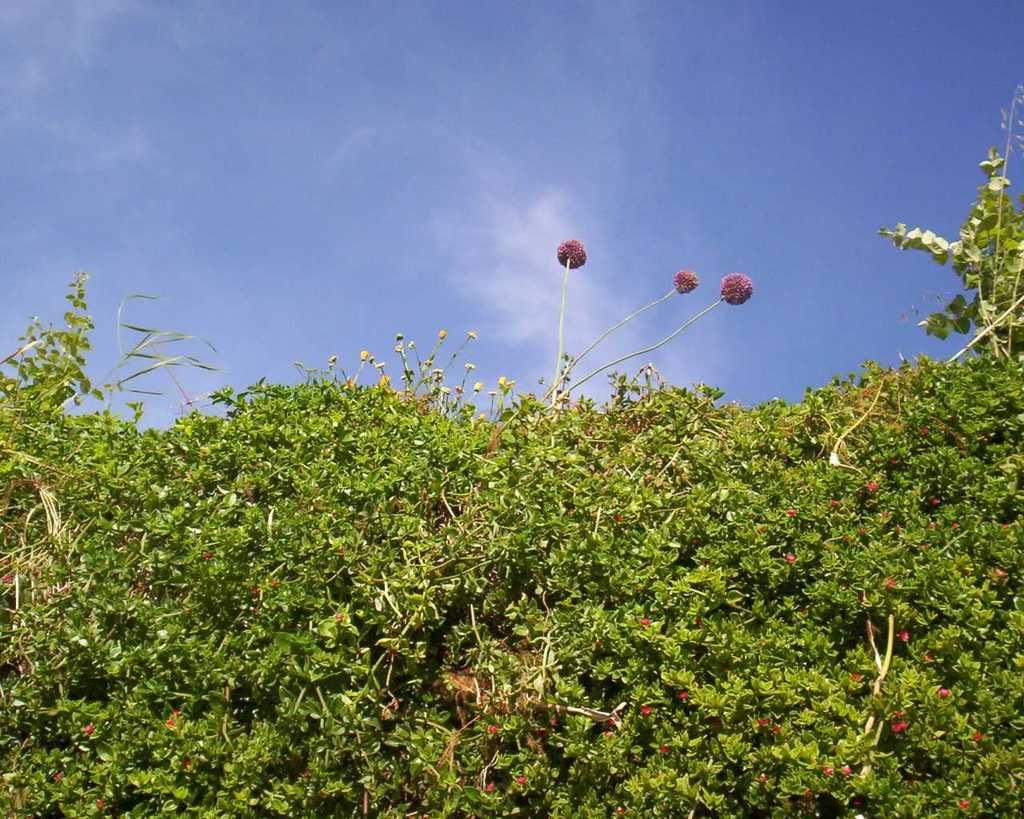What types of living organisms can be seen in the image? Plants and flowers are visible in the image. Can you describe the natural setting visible in the image? The natural setting includes plants and flowers, and the sky is visible in the background. What type of fruit can be seen hanging from the plants in the image? There is no fruit visible in the image; only plants and flowers are present. Can you describe the society of the tiger in the image? There is no tiger present in the image, so it is not possible to describe its society. 